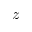<formula> <loc_0><loc_0><loc_500><loc_500>z</formula> 